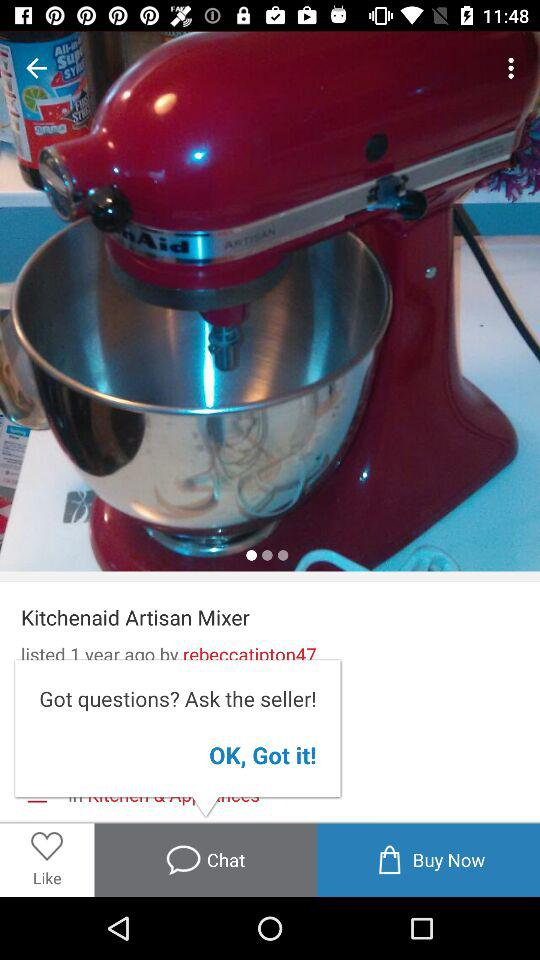Where is the seller located?
When the provided information is insufficient, respond with <no answer>. <no answer> 